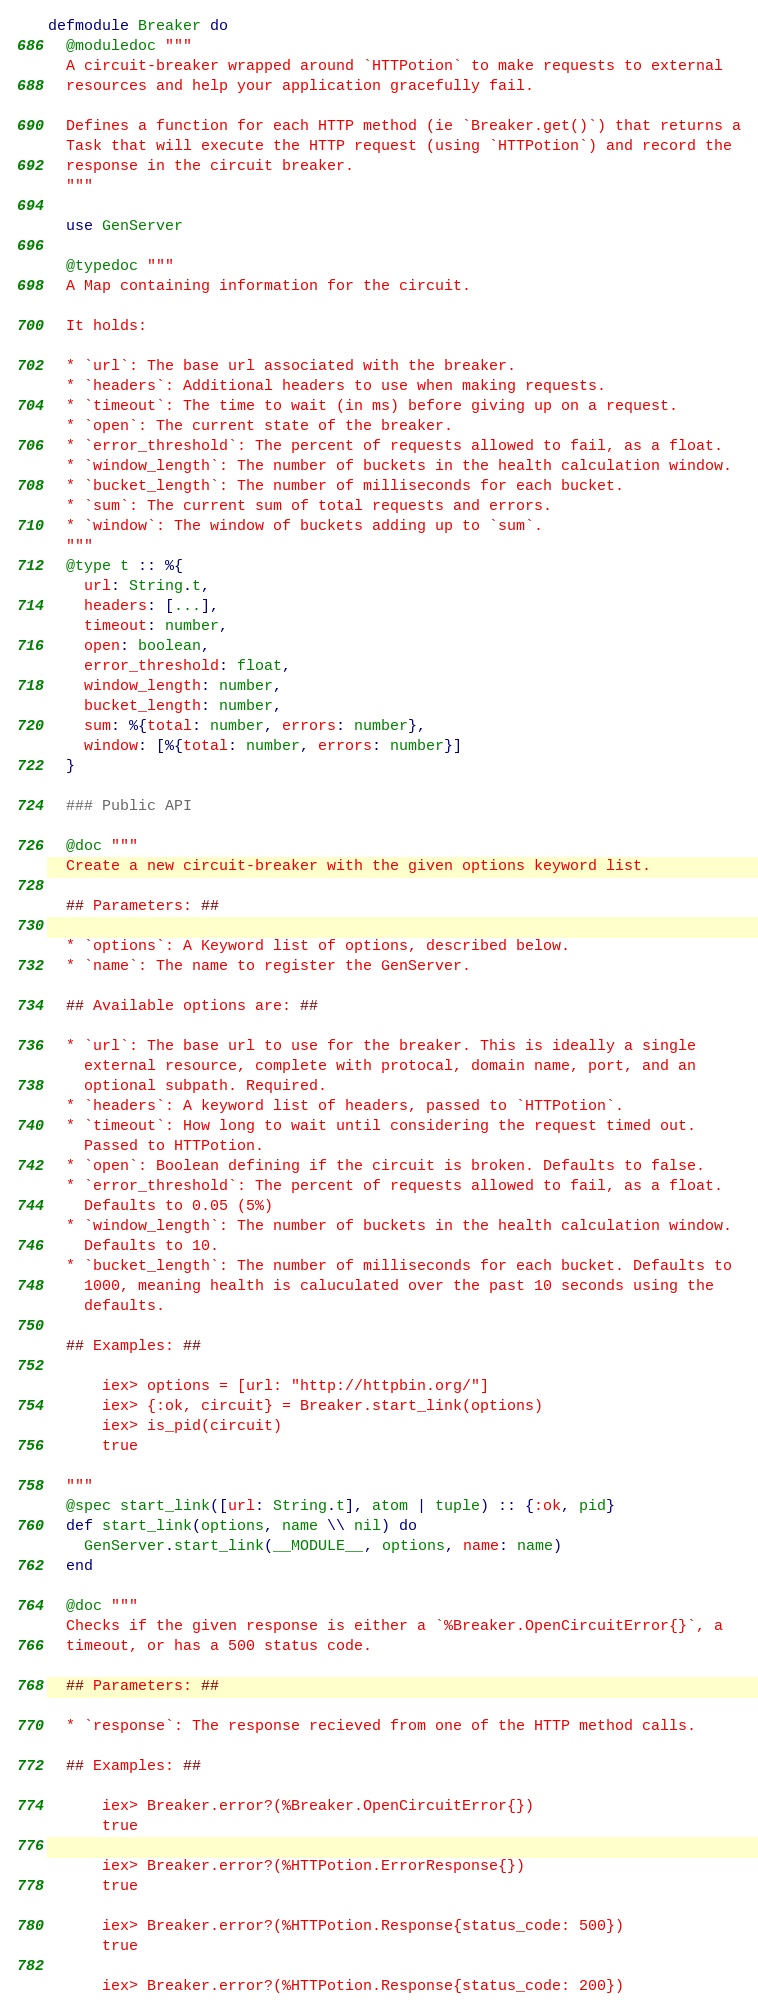Convert code to text. <code><loc_0><loc_0><loc_500><loc_500><_Elixir_>defmodule Breaker do
  @moduledoc """
  A circuit-breaker wrapped around `HTTPotion` to make requests to external
  resources and help your application gracefully fail.

  Defines a function for each HTTP method (ie `Breaker.get()`) that returns a
  Task that will execute the HTTP request (using `HTTPotion`) and record the
  response in the circuit breaker.
  """

  use GenServer

  @typedoc """
  A Map containing information for the circuit.

  It holds:

  * `url`: The base url associated with the breaker.
  * `headers`: Additional headers to use when making requests.
  * `timeout`: The time to wait (in ms) before giving up on a request.
  * `open`: The current state of the breaker.
  * `error_threshold`: The percent of requests allowed to fail, as a float.
  * `window_length`: The number of buckets in the health calculation window.
  * `bucket_length`: The number of milliseconds for each bucket.
  * `sum`: The current sum of total requests and errors.
  * `window`: The window of buckets adding up to `sum`.
  """
  @type t :: %{
    url: String.t,
    headers: [...],
    timeout: number,
    open: boolean,
    error_threshold: float,
    window_length: number,
    bucket_length: number,
    sum: %{total: number, errors: number},
    window: [%{total: number, errors: number}]
  }

  ### Public API

  @doc """
  Create a new circuit-breaker with the given options keyword list.

  ## Parameters: ##

  * `options`: A Keyword list of options, described below.
  * `name`: The name to register the GenServer.

  ## Available options are: ##

  * `url`: The base url to use for the breaker. This is ideally a single
    external resource, complete with protocal, domain name, port, and an
    optional subpath. Required.
  * `headers`: A keyword list of headers, passed to `HTTPotion`.
  * `timeout`: How long to wait until considering the request timed out.
    Passed to HTTPotion.
  * `open`: Boolean defining if the circuit is broken. Defaults to false.
  * `error_threshold`: The percent of requests allowed to fail, as a float.
    Defaults to 0.05 (5%)
  * `window_length`: The number of buckets in the health calculation window.
    Defaults to 10.
  * `bucket_length`: The number of milliseconds for each bucket. Defaults to
    1000, meaning health is caluculated over the past 10 seconds using the
    defaults.

  ## Examples: ##

      iex> options = [url: "http://httpbin.org/"]
      iex> {:ok, circuit} = Breaker.start_link(options)
      iex> is_pid(circuit)
      true

  """
  @spec start_link([url: String.t], atom | tuple) :: {:ok, pid}
  def start_link(options, name \\ nil) do
    GenServer.start_link(__MODULE__, options, name: name)
  end

  @doc """
  Checks if the given response is either a `%Breaker.OpenCircuitError{}`, a
  timeout, or has a 500 status code.

  ## Parameters: ##

  * `response`: The response recieved from one of the HTTP method calls.

  ## Examples: ##

      iex> Breaker.error?(%Breaker.OpenCircuitError{})
      true

      iex> Breaker.error?(%HTTPotion.ErrorResponse{})
      true

      iex> Breaker.error?(%HTTPotion.Response{status_code: 500})
      true

      iex> Breaker.error?(%HTTPotion.Response{status_code: 200})</code> 